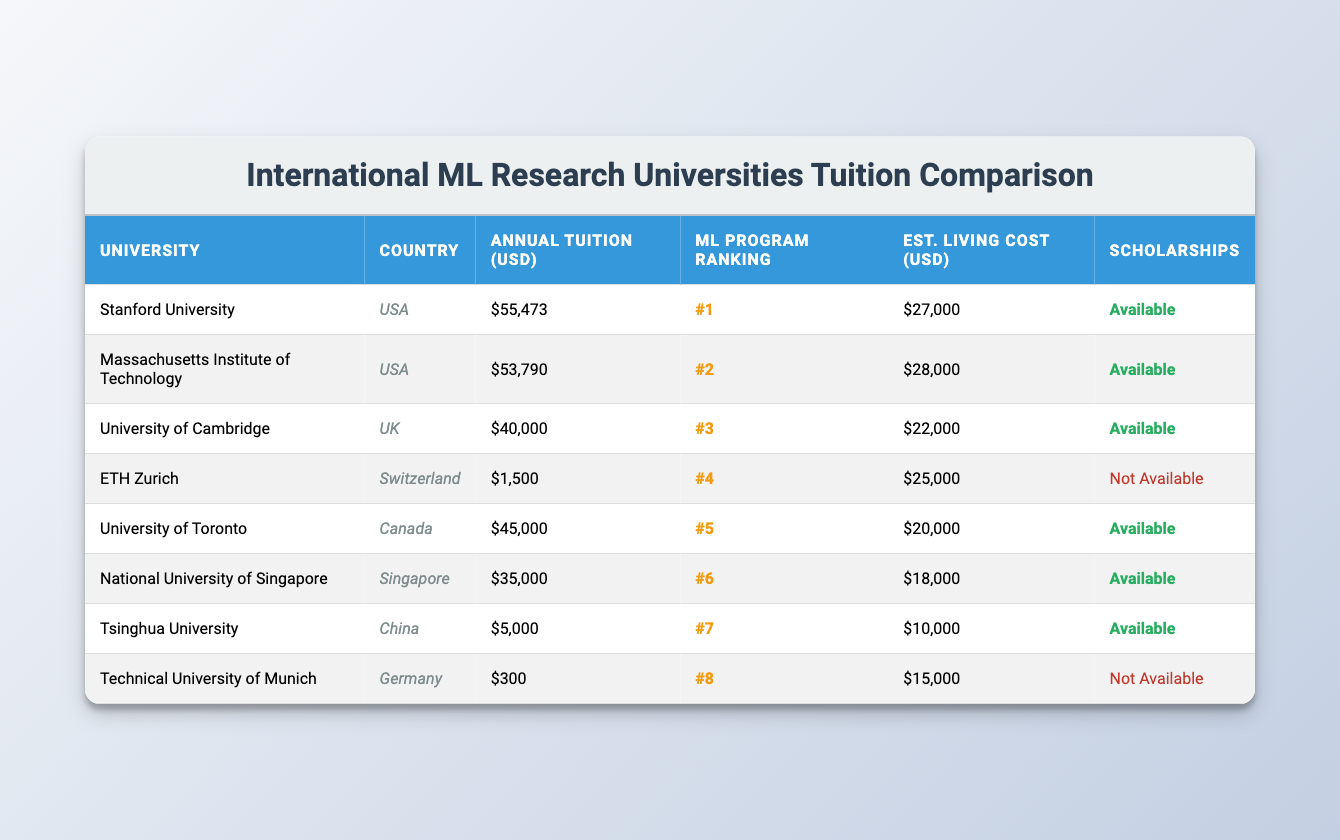What is the annual tuition fee for Stanford University? In the table, under the heading "Annual Tuition (USD)", the value for Stanford University is listed as $55,473.
Answer: $55,473 Which university has the lowest annual tuition fee? Scanning through the "Annual Tuition (USD)" column, ETH Zurich has the lowest fee listed at $1,500, compared to the other universities.
Answer: ETH Zurich What is the living cost estimate for the University of Toronto? The table shows the living cost estimate under the "Est. Living Cost (USD)" column for the University of Toronto, which is $20,000.
Answer: $20,000 How much more does Stanford University charge in tuition compared to ETH Zurich? To find the difference, subtract the tuition fee of ETH Zurich ($1,500) from Stanford University's tuition fee ($55,473): 55,473 - 1,500 = $53,973.
Answer: $53,973 Are scholarships available at Tsinghua University? In the "Scholarships" column for Tsinghua University, the entry is "Available", confirming the availability of scholarships.
Answer: Yes Which country has the highest average annual tuition fee among these universities? First, calculate the total tuition fees: 55473 + 53790 + 40000 + 1500 + 45000 + 35000 + 5000 + 300 = 195,063. Then find the average for the USA (2 universities) = 55,473 + 53,790 = 109,263 / 2 = 54,631. The UK (1) = 40,000, Switzerland (1) = 1,500, Canada (1) = 45,000, Singapore (1) = 35,000, China (1) = 5,000, Germany (1) = 300. The highest average comes from the USA.
Answer: USA What is the ranking of the National University of Singapore? The ranking is found in the "ML Program Ranking" column, where the National University of Singapore is listed with a ranking of #6.
Answer: #6 Which universities do not offer scholarships? Look in the "Scholarships" column for entries marked as "Not Available", which are for ETH Zurich and the Technical University of Munich.
Answer: ETH Zurich and Technical University of Munich What is the difference between the living cost estimates of Stanford University and Tsinghua University? Subtract the living cost for Tsinghua University ($10,000) from Stanford University ($27,000): 27,000 - 10,000 = 17,000.
Answer: $17,000 